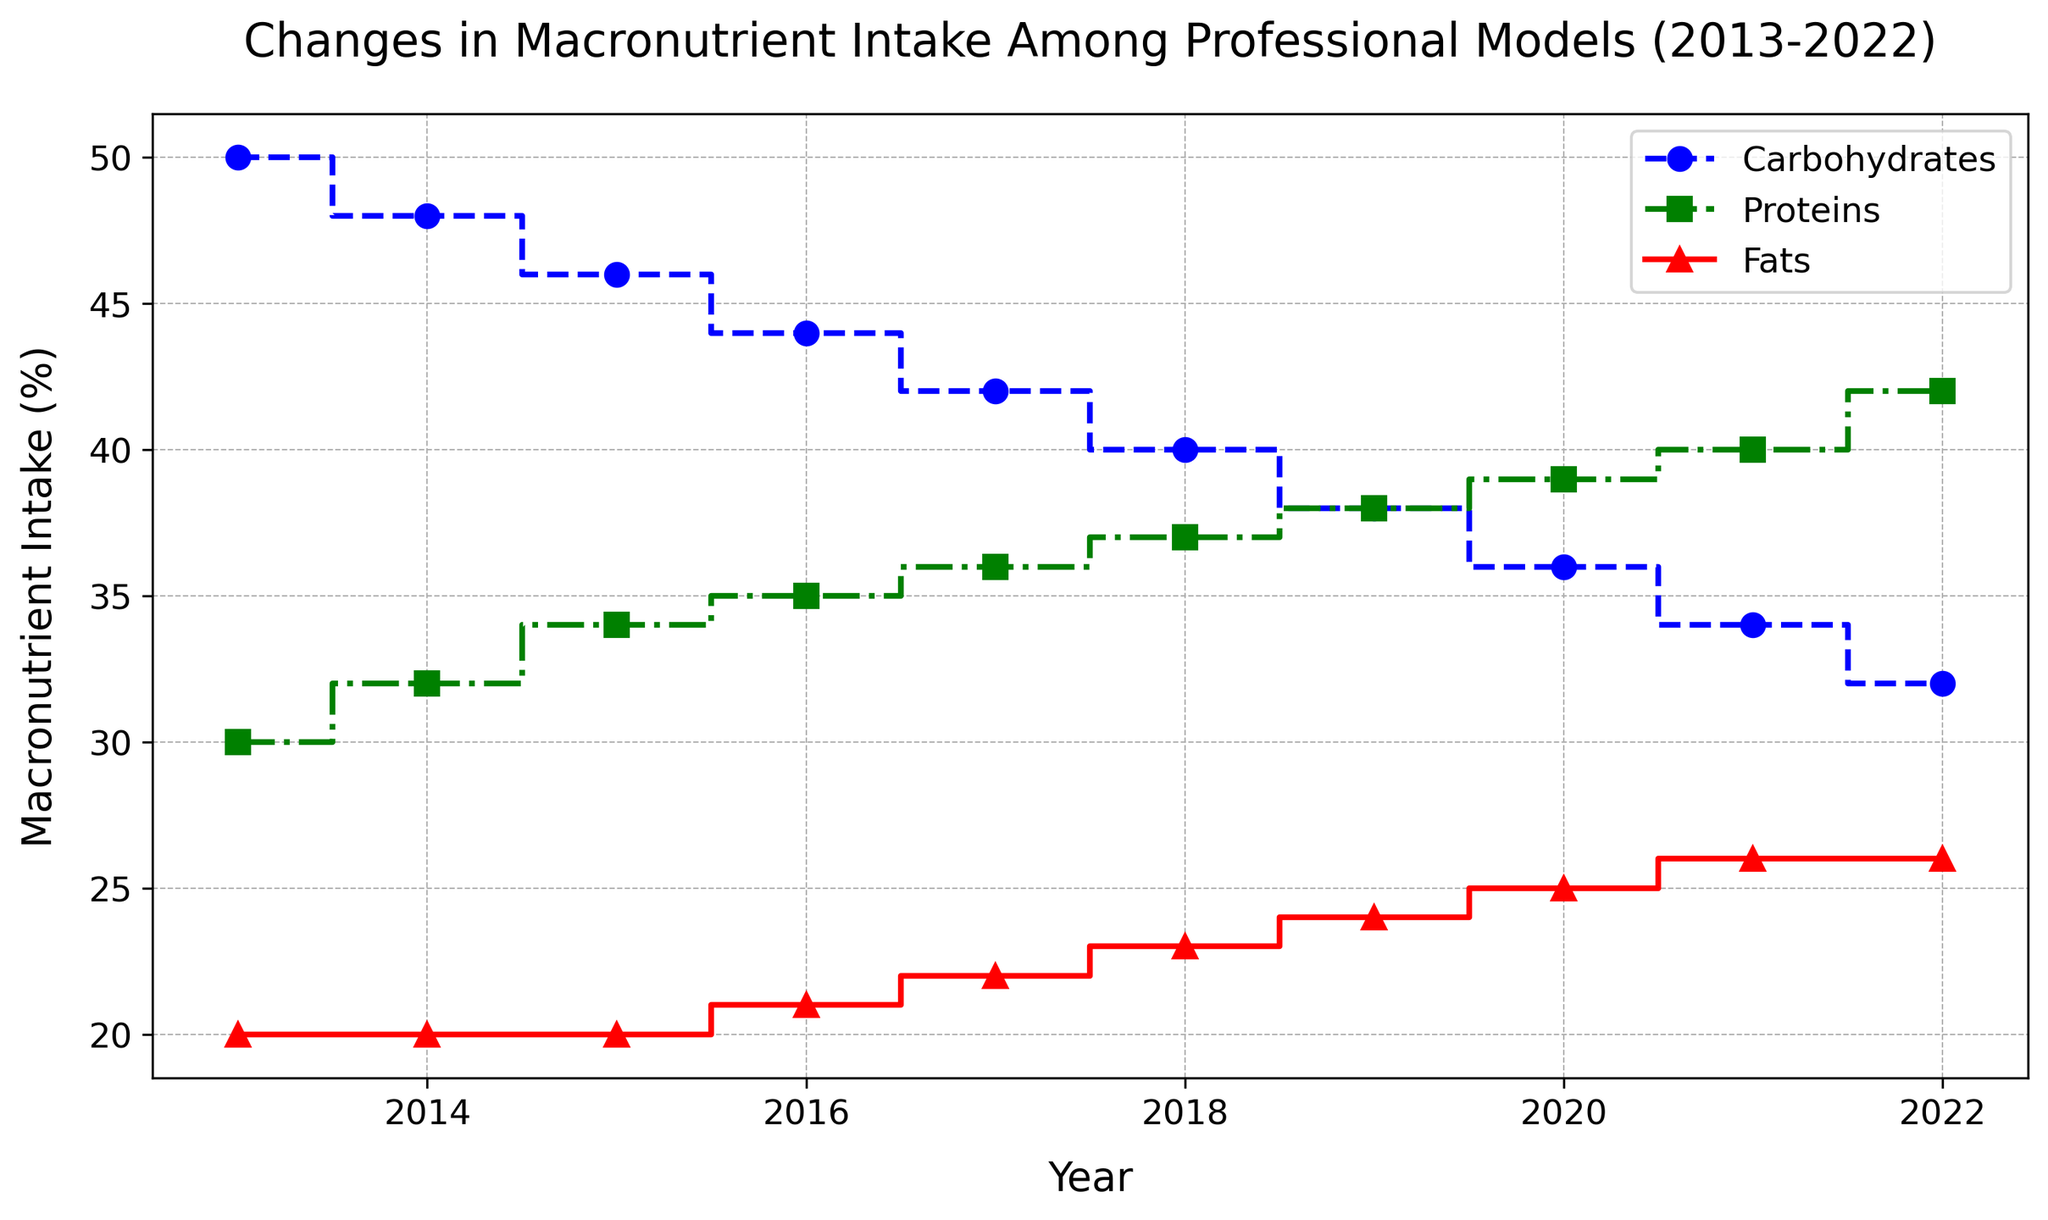What is the overall trend in carbohydrate intake from 2013 to 2022? By observing the blue stairs plot, we see a continuous decrease in the carbohydrate intake over the years. Starting from 50% in 2013 and dropping to 32% in 2022, the trend is clearly downward.
Answer: Decreasing Which year has the highest intake of proteins? Checking the green stairs plot, we note that the protein intake reaches its peak in 2022 with a value of 42%.
Answer: 2022 By how much did the fat intake increase from 2013 to 2022? The red stairs plot shows the fat intake increasing from 20% in 2013 to 26% in 2022. The difference can be calculated as 26% - 20% = 6%.
Answer: 6% Which macronutrient had the most significant change in percentage over the decade? Carbohydrates decreased from 50% to 32% showing an 18% drop, Proteins increased from 30% to 42% showing a 12% rise, and Fats increased from 20% to 26% showing a 6% rise. Therefore, the most significant change is in carbohydrates.
Answer: Carbohydrates In which year did carbohydrates and proteins have the same intake? By observing both the blue (carbohydrates) and green (proteins) stairs plots, we can see that they intersect in 2022 where both have the same intake of 42%.
Answer: 2022 What is the sum of the percentages of fat intake for the years 2018, 2019, and 2020? From the red stairs plot, we find the fat intake values for the years 2018, 2019, and 2020 are 23%, 24%, and 25% respectively. The sum is calculated as 23% + 24% + 25% = 72%.
Answer: 72% How did the intake of proteins change between 2015 and 2017? Checking the green stairs plot, the protein intake increased from 34% in 2015 to 36% in 2017. This shows a 2% rise.
Answer: Increased by 2% Visualizing the trend, which macronutrient has consistently risen in intake over the decade? Both the green (proteins) and red (fats) stairs plots show an upward trend, but proteins have consistently risen without any interruptions from 30% to 42%.
Answer: Proteins 